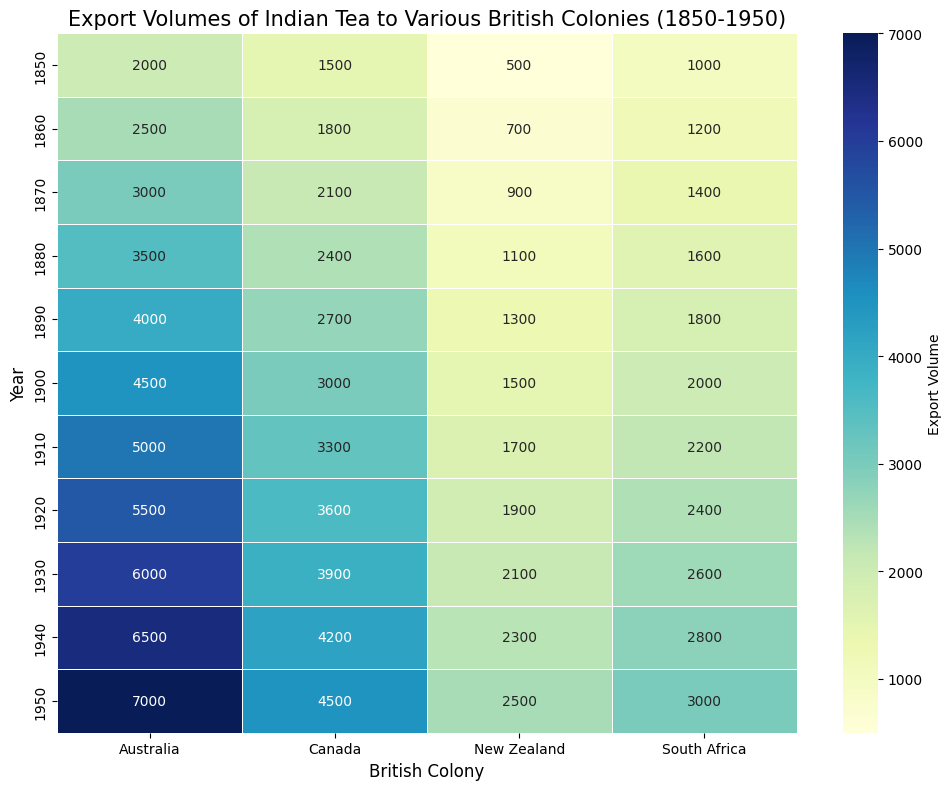What year had the highest export volume of Indian tea to Australia? The heatmap shows the export volume over various years. Look for the darkest shade representing the highest value in the column for Australia. The darkest shade is found in the row for 1950 with a value of 7000.
Answer: 1950 Which British colony had the lowest export volume of Indian tea in 1850? Check the row for the year 1850 and identify the lightest shade in that row, representing the lowest value. The lightest shade is in the New Zealand column, with a value of 500.
Answer: New Zealand How did the export volume to Canada change from 1850 to 1950? Look at the Canada column and compare the values for the years 1850 (1500) and 1950 (4500). To calculate the change, subtract the initial value from the final value: 4500 - 1500 = 3000.
Answer: Increased by 3000 What was the sum of the export volumes to South Africa in the years 1860 and 1870? Identify the values for South Africa in the years 1860 (1200) and 1870 (1400), then add these values together. The sum is 1200 + 1400 = 2600.
Answer: 2600 Which year shows the smallest difference in export volumes between Australia and South Africa? Calculate the differences between the export volumes for Australia and South Africa in each year and find the smallest difference. For example, in 1850 (difference = 2000 - 1000 = 1000), 1860 (difference = 2500 - 1200 = 1300), etc. The smallest difference is in 1850 with 1000.
Answer: 1850 Which British colony had the second highest export volume in 1930? Look at the row for the year 1930 and identify the values in descending order. The highest value is for Australia (6000), followed by Canada (3900). Therefore, Canada had the second highest export volume.
Answer: Canada What is the average export volume to New Zealand over the given years? Sum all the export values for New Zealand from 1850 to 1950: 500 + 700 + 900 + 1100 + 1300 + 1500 + 1700 + 1900 + 2100 + 2300 + 2500 = 15500. Divide this sum by the number of years (11): 15500 / 11 = 1409 (approx).
Answer: 1409 In which decade did South Africa see the greatest increase in export volume? Compare the differences in export volumes for South Africa between each decade: 1850-1860 (200), 1860-1870 (200), ..., 1940-1950 (200). The greatest increase is the same in each decade with an increase of 200.
Answer: 1850-1950 (All decades) Which British colony shows the steadiest increase in export volumes over the years? Assess the export volumes for each colony and determine the one with the most consistent increases. Australia shows a steady increase from 2000 in 1850 to 7000 in 1950, with no significant changes in the rate of increase.
Answer: Australia 